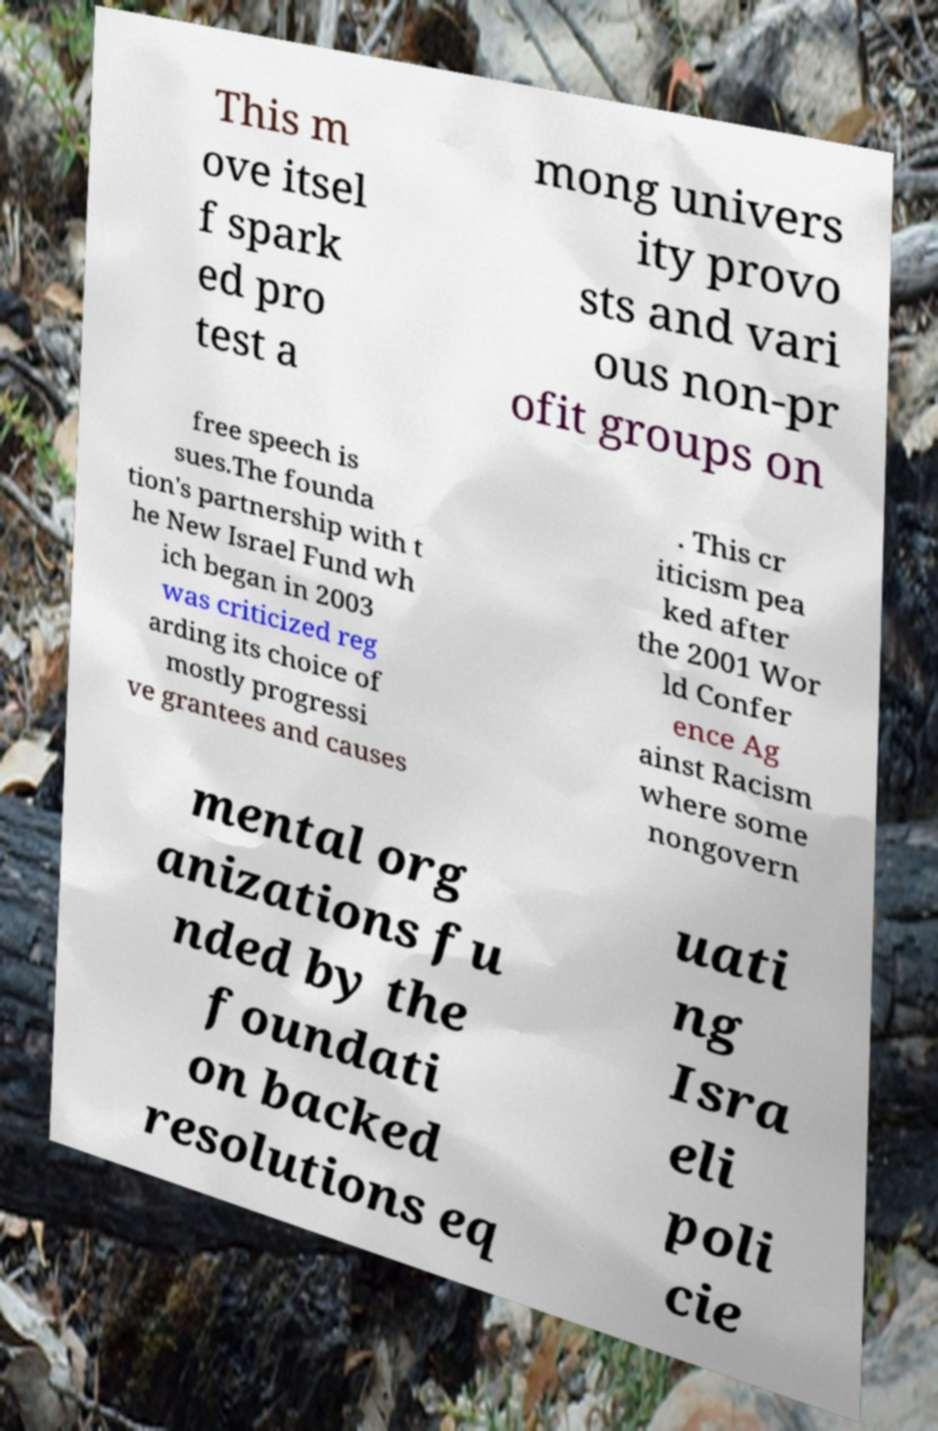For documentation purposes, I need the text within this image transcribed. Could you provide that? This m ove itsel f spark ed pro test a mong univers ity provo sts and vari ous non-pr ofit groups on free speech is sues.The founda tion's partnership with t he New Israel Fund wh ich began in 2003 was criticized reg arding its choice of mostly progressi ve grantees and causes . This cr iticism pea ked after the 2001 Wor ld Confer ence Ag ainst Racism where some nongovern mental org anizations fu nded by the foundati on backed resolutions eq uati ng Isra eli poli cie 